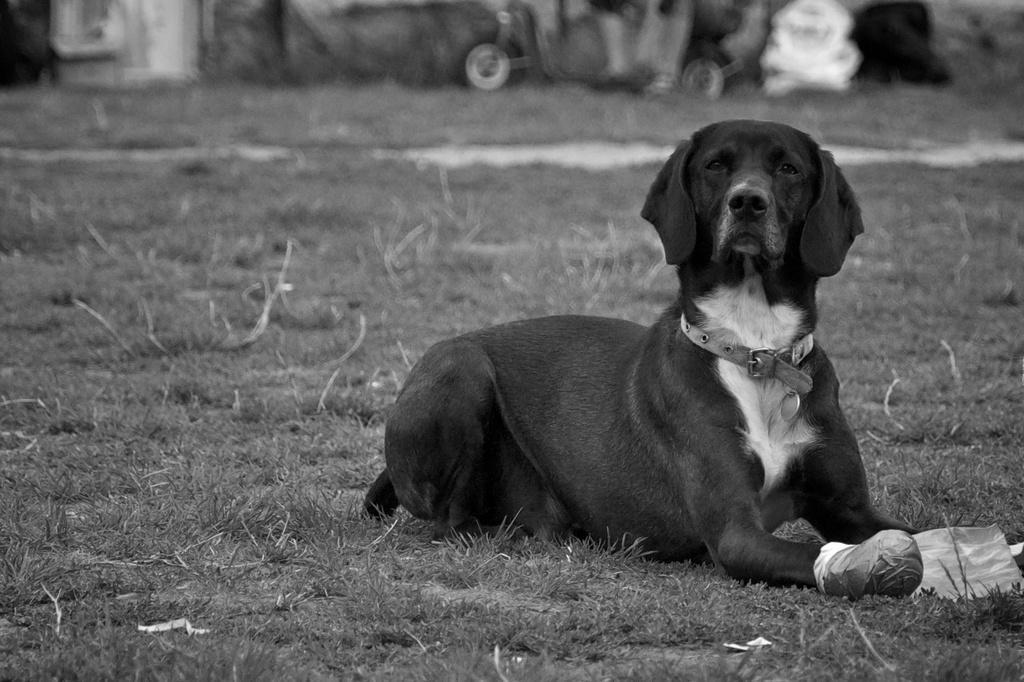Please provide a concise description of this image. It is a black and white picture. In the center of the image we can see one dog, which is in black and white color. And we can see one belt around the dog's neck. And we can see some plastic tape wrapped on the dog's paw. In front of dog, we can see one paper. In the background we can see one vehicle, black and white color objects, grass and a few other objects. 